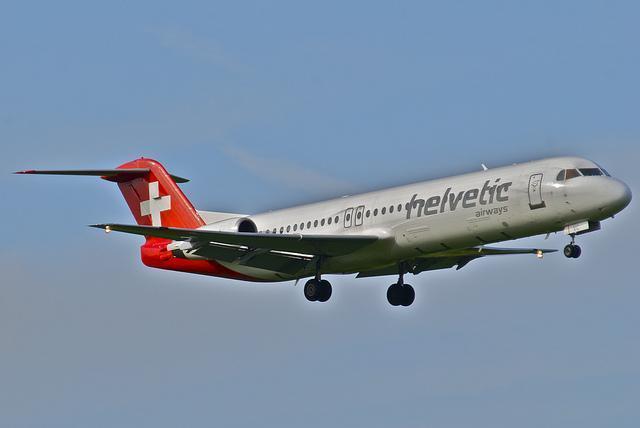How many jets are there?
Give a very brief answer. 1. 